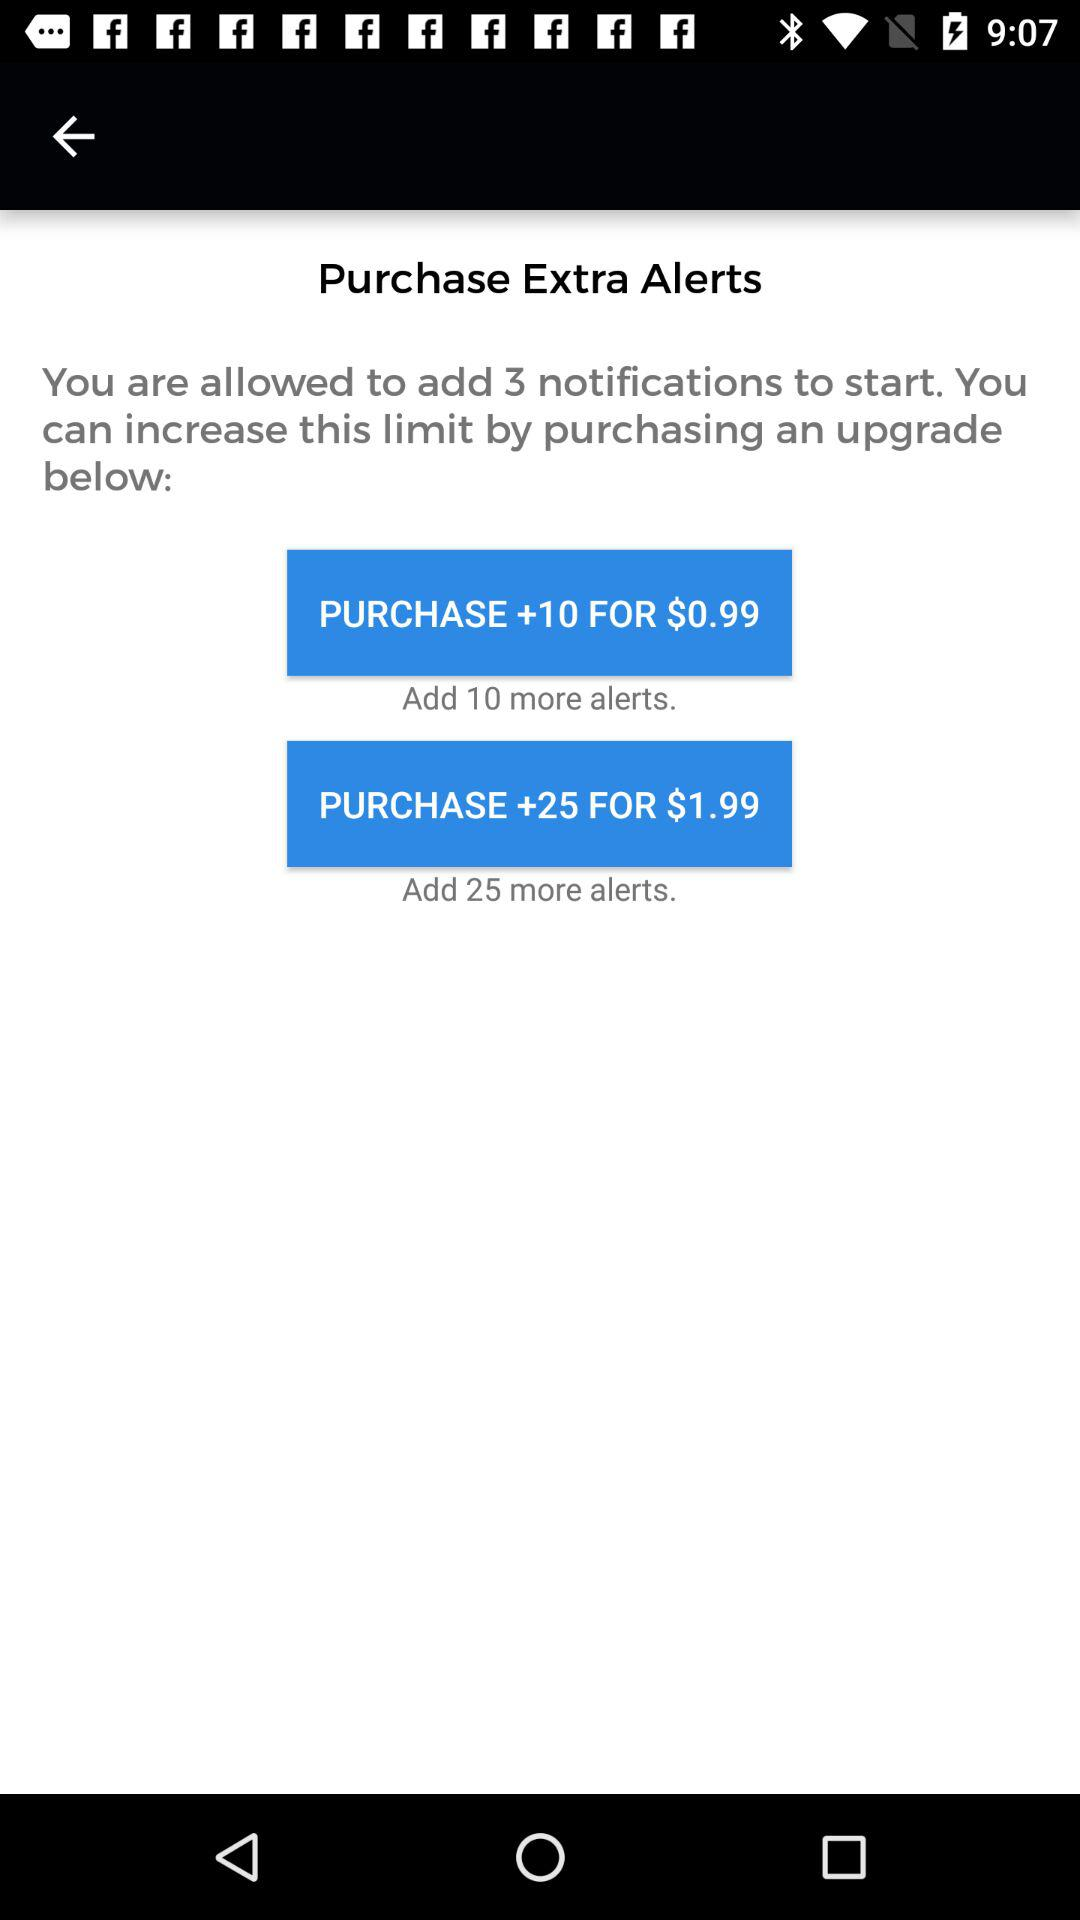How many notifications are allowed to be added prior to the start? There are 3 notifications that are allowed to be added prior to the start. 